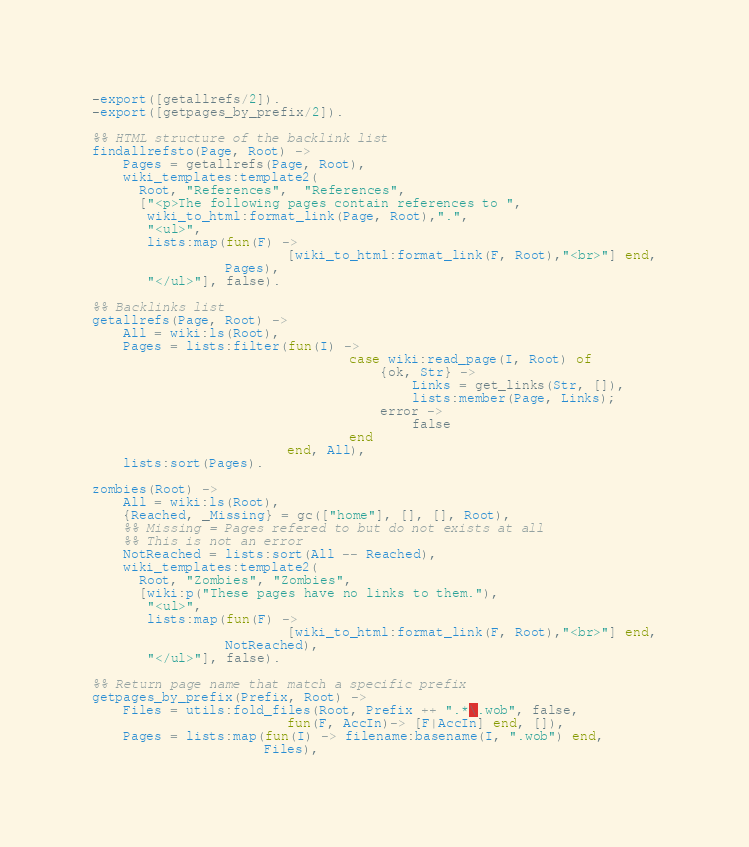<code> <loc_0><loc_0><loc_500><loc_500><_Erlang_>-export([getallrefs/2]).
-export([getpages_by_prefix/2]).

%% HTML structure of the backlink list
findallrefsto(Page, Root) ->
    Pages = getallrefs(Page, Root),
    wiki_templates:template2(
      Root, "References",  "References",
      ["<p>The following pages contain references to ",
       wiki_to_html:format_link(Page, Root),".",
       "<ul>",
       lists:map(fun(F) ->
                         [wiki_to_html:format_link(F, Root),"<br>"] end,
                 Pages),
       "</ul>"], false).

%% Backlinks list
getallrefs(Page, Root) ->
    All = wiki:ls(Root),
    Pages = lists:filter(fun(I) ->
                                 case wiki:read_page(I, Root) of
                                     {ok, Str} ->
                                         Links = get_links(Str, []),
                                         lists:member(Page, Links);
                                     error ->
                                         false
                                 end
                         end, All),
    lists:sort(Pages).

zombies(Root) ->
    All = wiki:ls(Root),
    {Reached, _Missing} = gc(["home"], [], [], Root),
    %% Missing = Pages refered to but do not exists at all
    %% This is not an error
    NotReached = lists:sort(All -- Reached),
    wiki_templates:template2(
      Root, "Zombies", "Zombies",
      [wiki:p("These pages have no links to them."),
       "<ul>",
       lists:map(fun(F) ->
                         [wiki_to_html:format_link(F, Root),"<br>"] end,
                 NotReached),
       "</ul>"], false).

%% Return page name that match a specific prefix
getpages_by_prefix(Prefix, Root) ->
    Files = utils:fold_files(Root, Prefix ++ ".*\.wob", false,
                         fun(F, AccIn)-> [F|AccIn] end, []),
    Pages = lists:map(fun(I) -> filename:basename(I, ".wob") end,
                      Files),</code> 